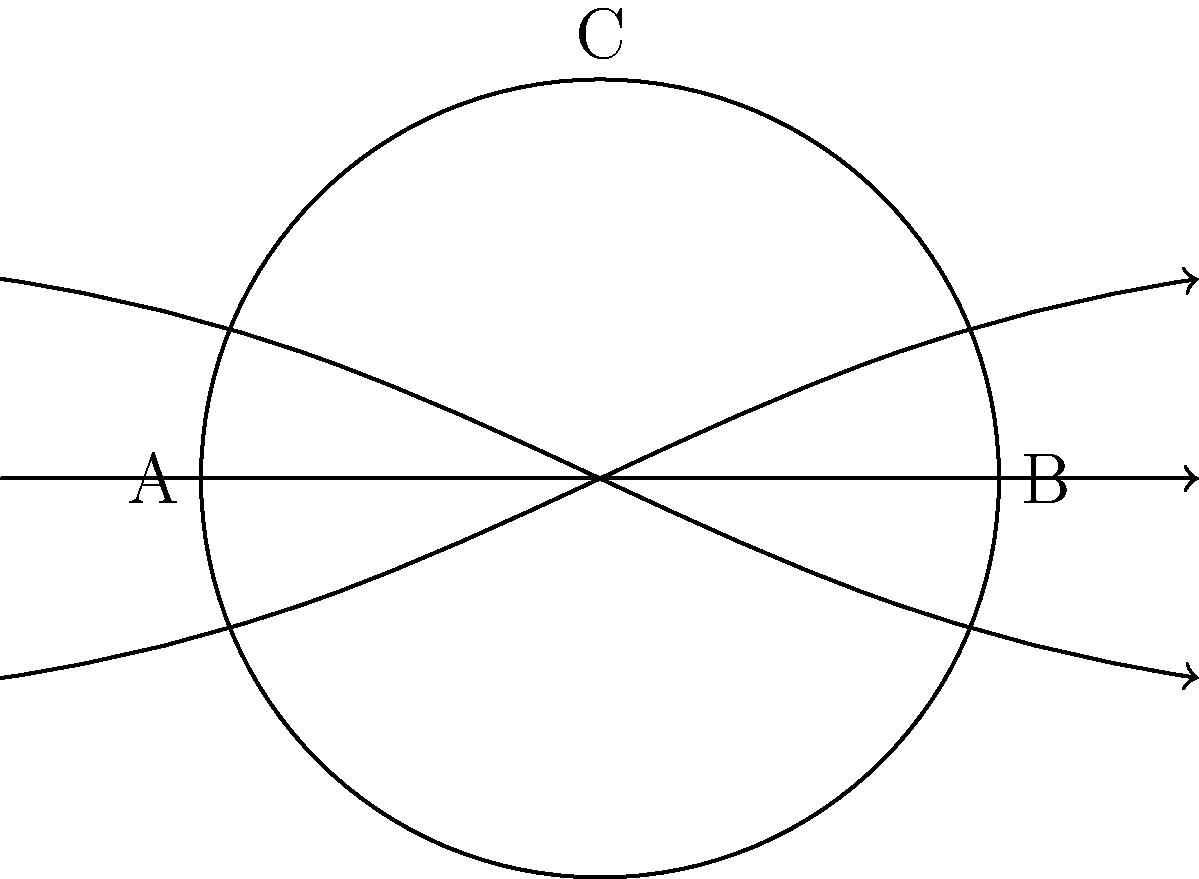In the diagram inspired by Magnemite's levitation abilities, magnetic field lines are shown around a spherical object. If the magnetic field strength at point A is $2\text{ T}$ and the field strength at point B is $8\text{ T}$, what is the approximate magnetic field strength at point C? Assume the field strength follows an inverse square law relation with distance from the center of the sphere. To solve this problem, we'll follow these steps:

1) First, recall that for an inverse square law, the field strength $B$ is proportional to $\frac{1}{r^2}$, where $r$ is the distance from the center of the sphere.

2) Let's denote the radius of the sphere as $R$. Then:
   - Point A is at distance $R$ from the center
   - Point B is at distance $R$ from the center
   - Point C is at distance $R$ from the center

3) We're given that:
   - At point A: $B_A = 2\text{ T}$
   - At point B: $B_B = 8\text{ T}$

4) The field strength at point C ($B_C$) will be between these values, as C is equidistant from the center as A and B.

5) In a symmetric field, we can estimate $B_C$ as the geometric mean of $B_A$ and $B_B$:

   $$B_C \approx \sqrt{B_A \cdot B_B}$$

6) Substituting the values:

   $$B_C \approx \sqrt{2\text{ T} \cdot 8\text{ T}} = \sqrt{16\text{ T}^2} = 4\text{ T}$$

Therefore, the approximate magnetic field strength at point C is 4 T.
Answer: 4 T 